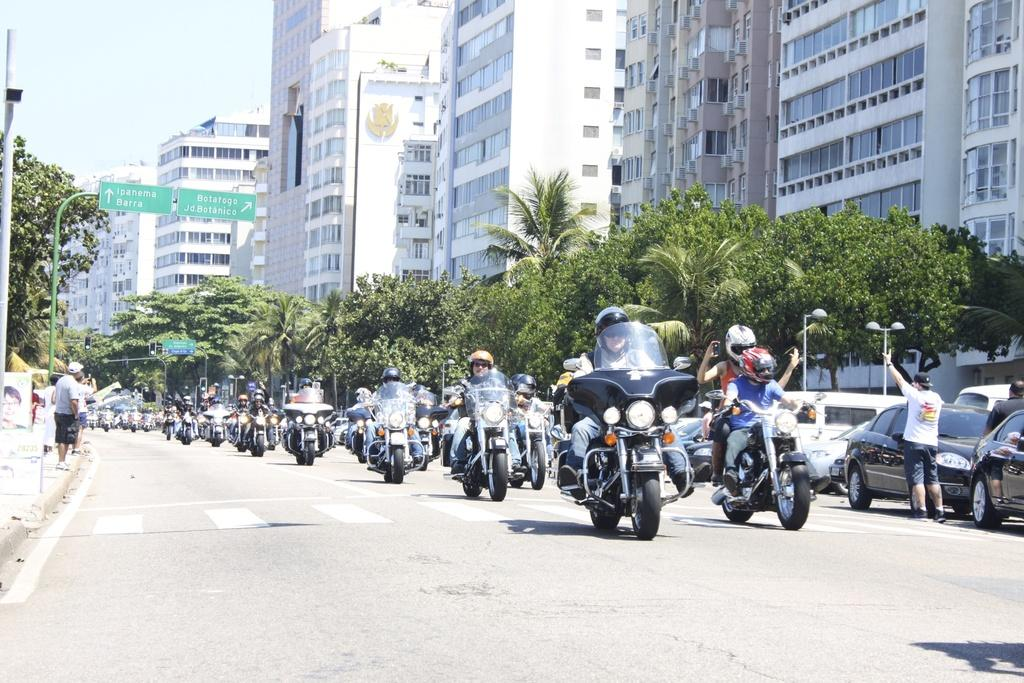What type of structure is visible in the image? There is a building in the image. What activity are some people engaged in? There are people riding bikes in the image. What type of vehicles can be seen parked in the image? There are parked cars in the image. What grade of crackers can be seen in the image? There is no mention of crackers in the image, so it is impossible to determine the grade. 